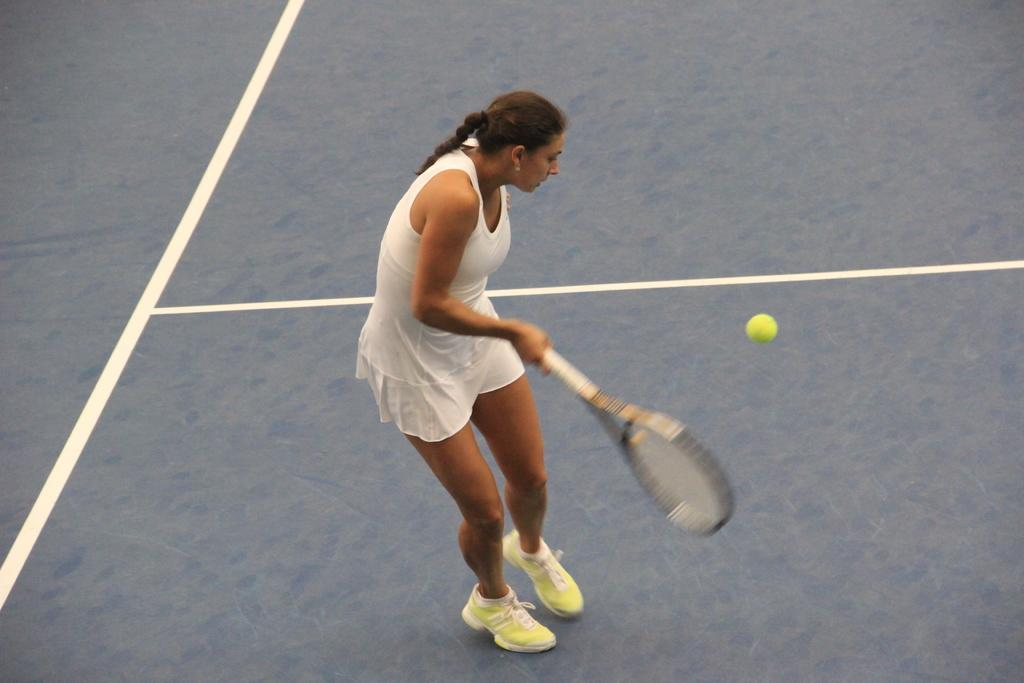Who is the main subject in the image? There is a woman in the image. What is the woman doing in the image? The woman is playing tennis. What object is the woman holding in the image? The woman is holding a tennis racket. What action is the woman performing with the tennis racket? The woman is hitting a ball with the racket. What type of music is the woman listening to while playing tennis in the image? There is no indication in the image that the woman is listening to music, so it cannot be determined from the picture. 